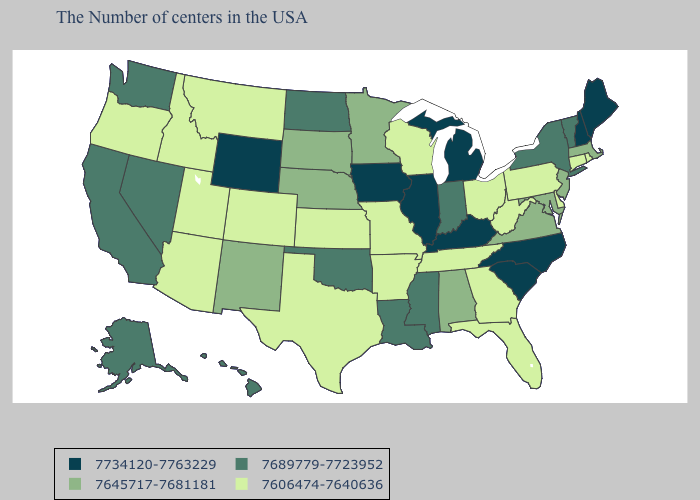Does Pennsylvania have the highest value in the Northeast?
Quick response, please. No. What is the value of Montana?
Keep it brief. 7606474-7640636. What is the highest value in the USA?
Give a very brief answer. 7734120-7763229. Does the map have missing data?
Write a very short answer. No. What is the lowest value in states that border Iowa?
Short answer required. 7606474-7640636. Name the states that have a value in the range 7645717-7681181?
Answer briefly. Massachusetts, New Jersey, Maryland, Virginia, Alabama, Minnesota, Nebraska, South Dakota, New Mexico. What is the value of Idaho?
Write a very short answer. 7606474-7640636. What is the value of Delaware?
Keep it brief. 7606474-7640636. Does Michigan have the lowest value in the USA?
Concise answer only. No. What is the value of Utah?
Give a very brief answer. 7606474-7640636. What is the lowest value in states that border Missouri?
Write a very short answer. 7606474-7640636. What is the value of New Mexico?
Answer briefly. 7645717-7681181. Does Nevada have the highest value in the USA?
Be succinct. No. Among the states that border Wyoming , does Colorado have the highest value?
Quick response, please. No. Name the states that have a value in the range 7606474-7640636?
Give a very brief answer. Rhode Island, Connecticut, Delaware, Pennsylvania, West Virginia, Ohio, Florida, Georgia, Tennessee, Wisconsin, Missouri, Arkansas, Kansas, Texas, Colorado, Utah, Montana, Arizona, Idaho, Oregon. 